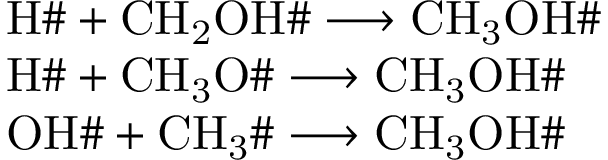<formula> <loc_0><loc_0><loc_500><loc_500>\begin{array} { r l } & { H \# + C H _ { 2 } O H \# \longrightarrow C H _ { 3 } O H \# } \\ & { H \# + C H _ { 3 } O \# \longrightarrow C H _ { 3 } O H \# } \\ & { O H \# + C H _ { 3 } \# \longrightarrow C H _ { 3 } O H \# } \end{array}</formula> 